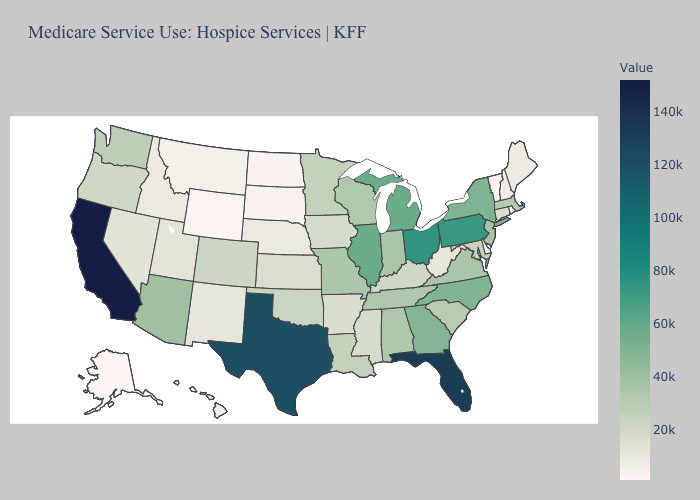Among the states that border Michigan , which have the highest value?
Be succinct. Ohio. Does Alaska have the lowest value in the West?
Quick response, please. Yes. Does the map have missing data?
Short answer required. No. Does Alaska have the lowest value in the USA?
Be succinct. Yes. Among the states that border Virginia , does Maryland have the highest value?
Be succinct. No. Which states have the lowest value in the USA?
Answer briefly. Alaska. Does Vermont have the lowest value in the Northeast?
Keep it brief. Yes. Does Connecticut have a lower value than Alaska?
Quick response, please. No. 